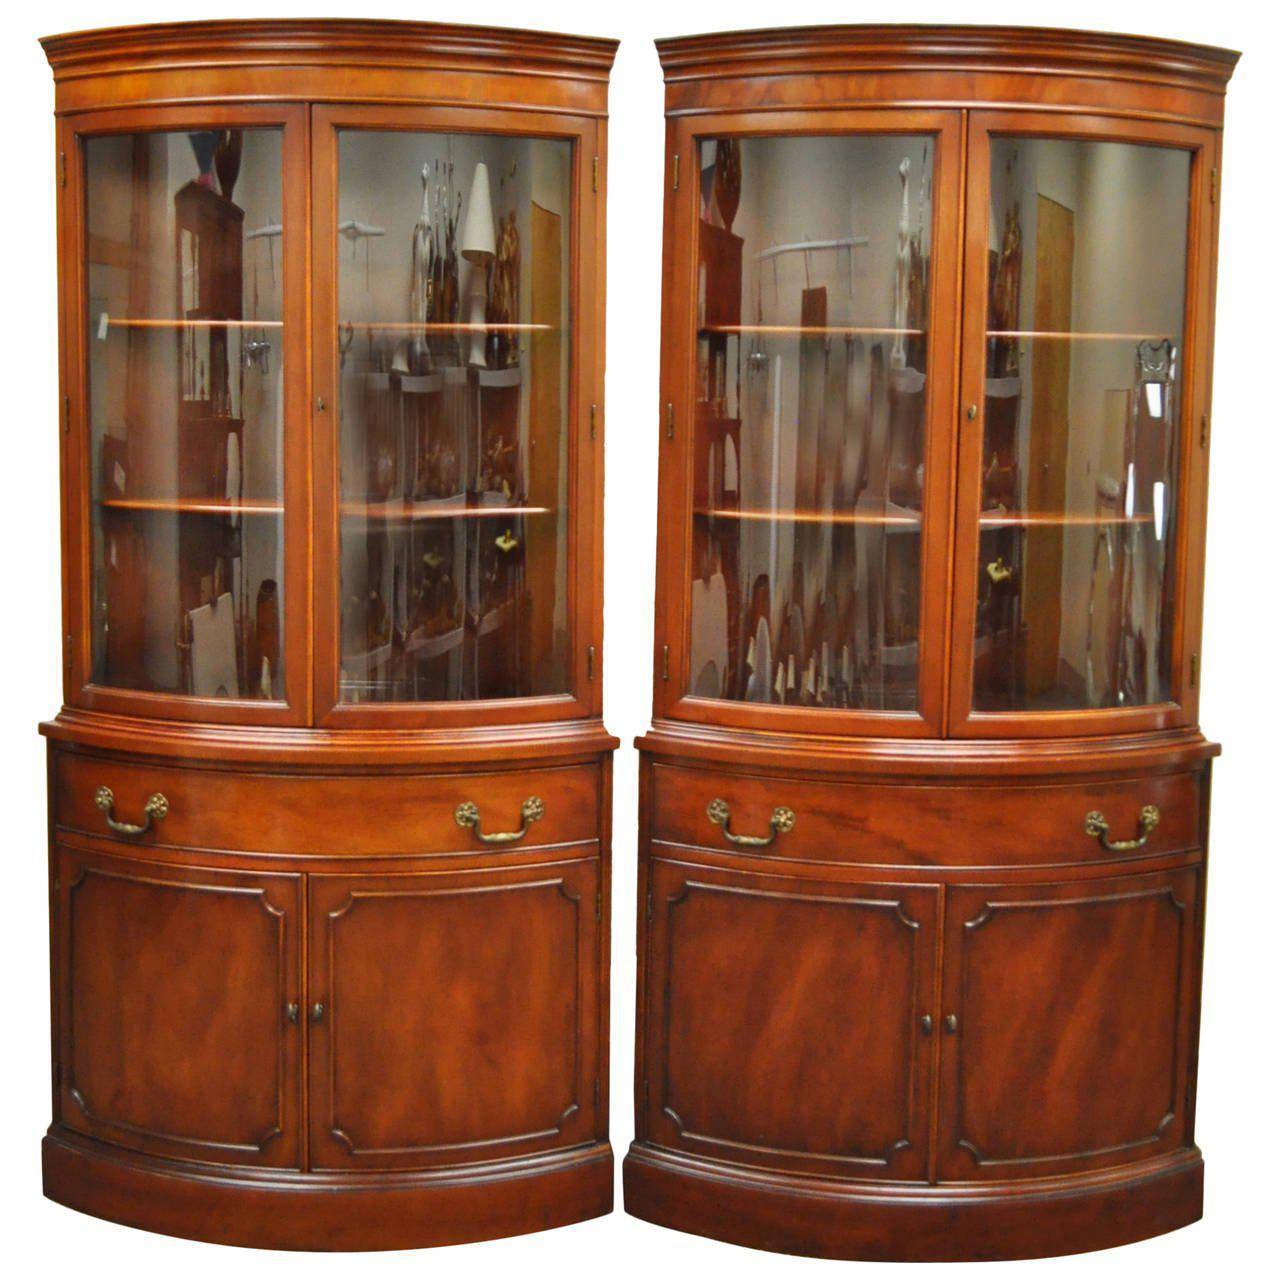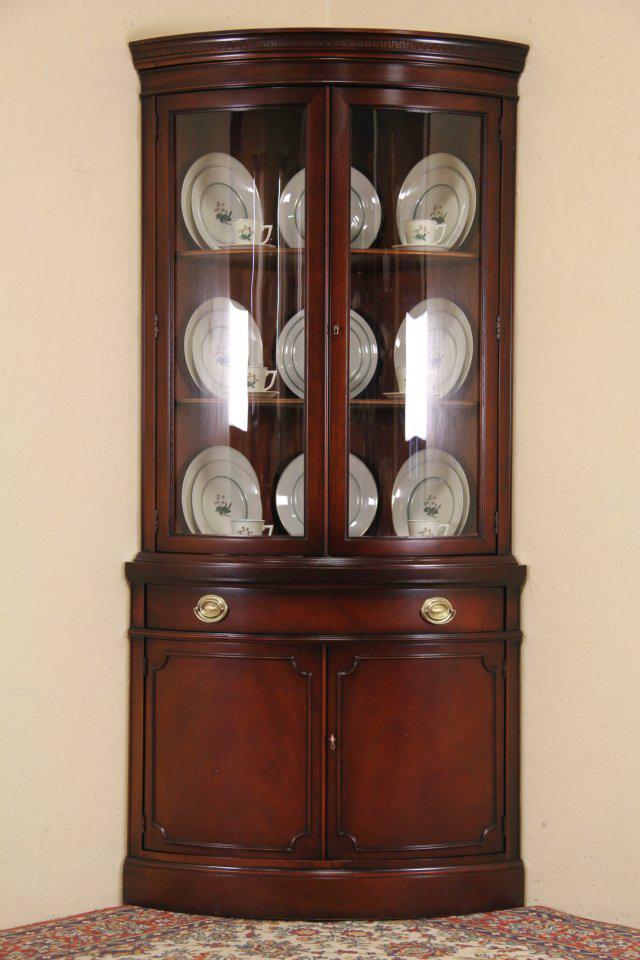The first image is the image on the left, the second image is the image on the right. Given the left and right images, does the statement "a picture frame is visible on the right image." hold true? Answer yes or no. No. 